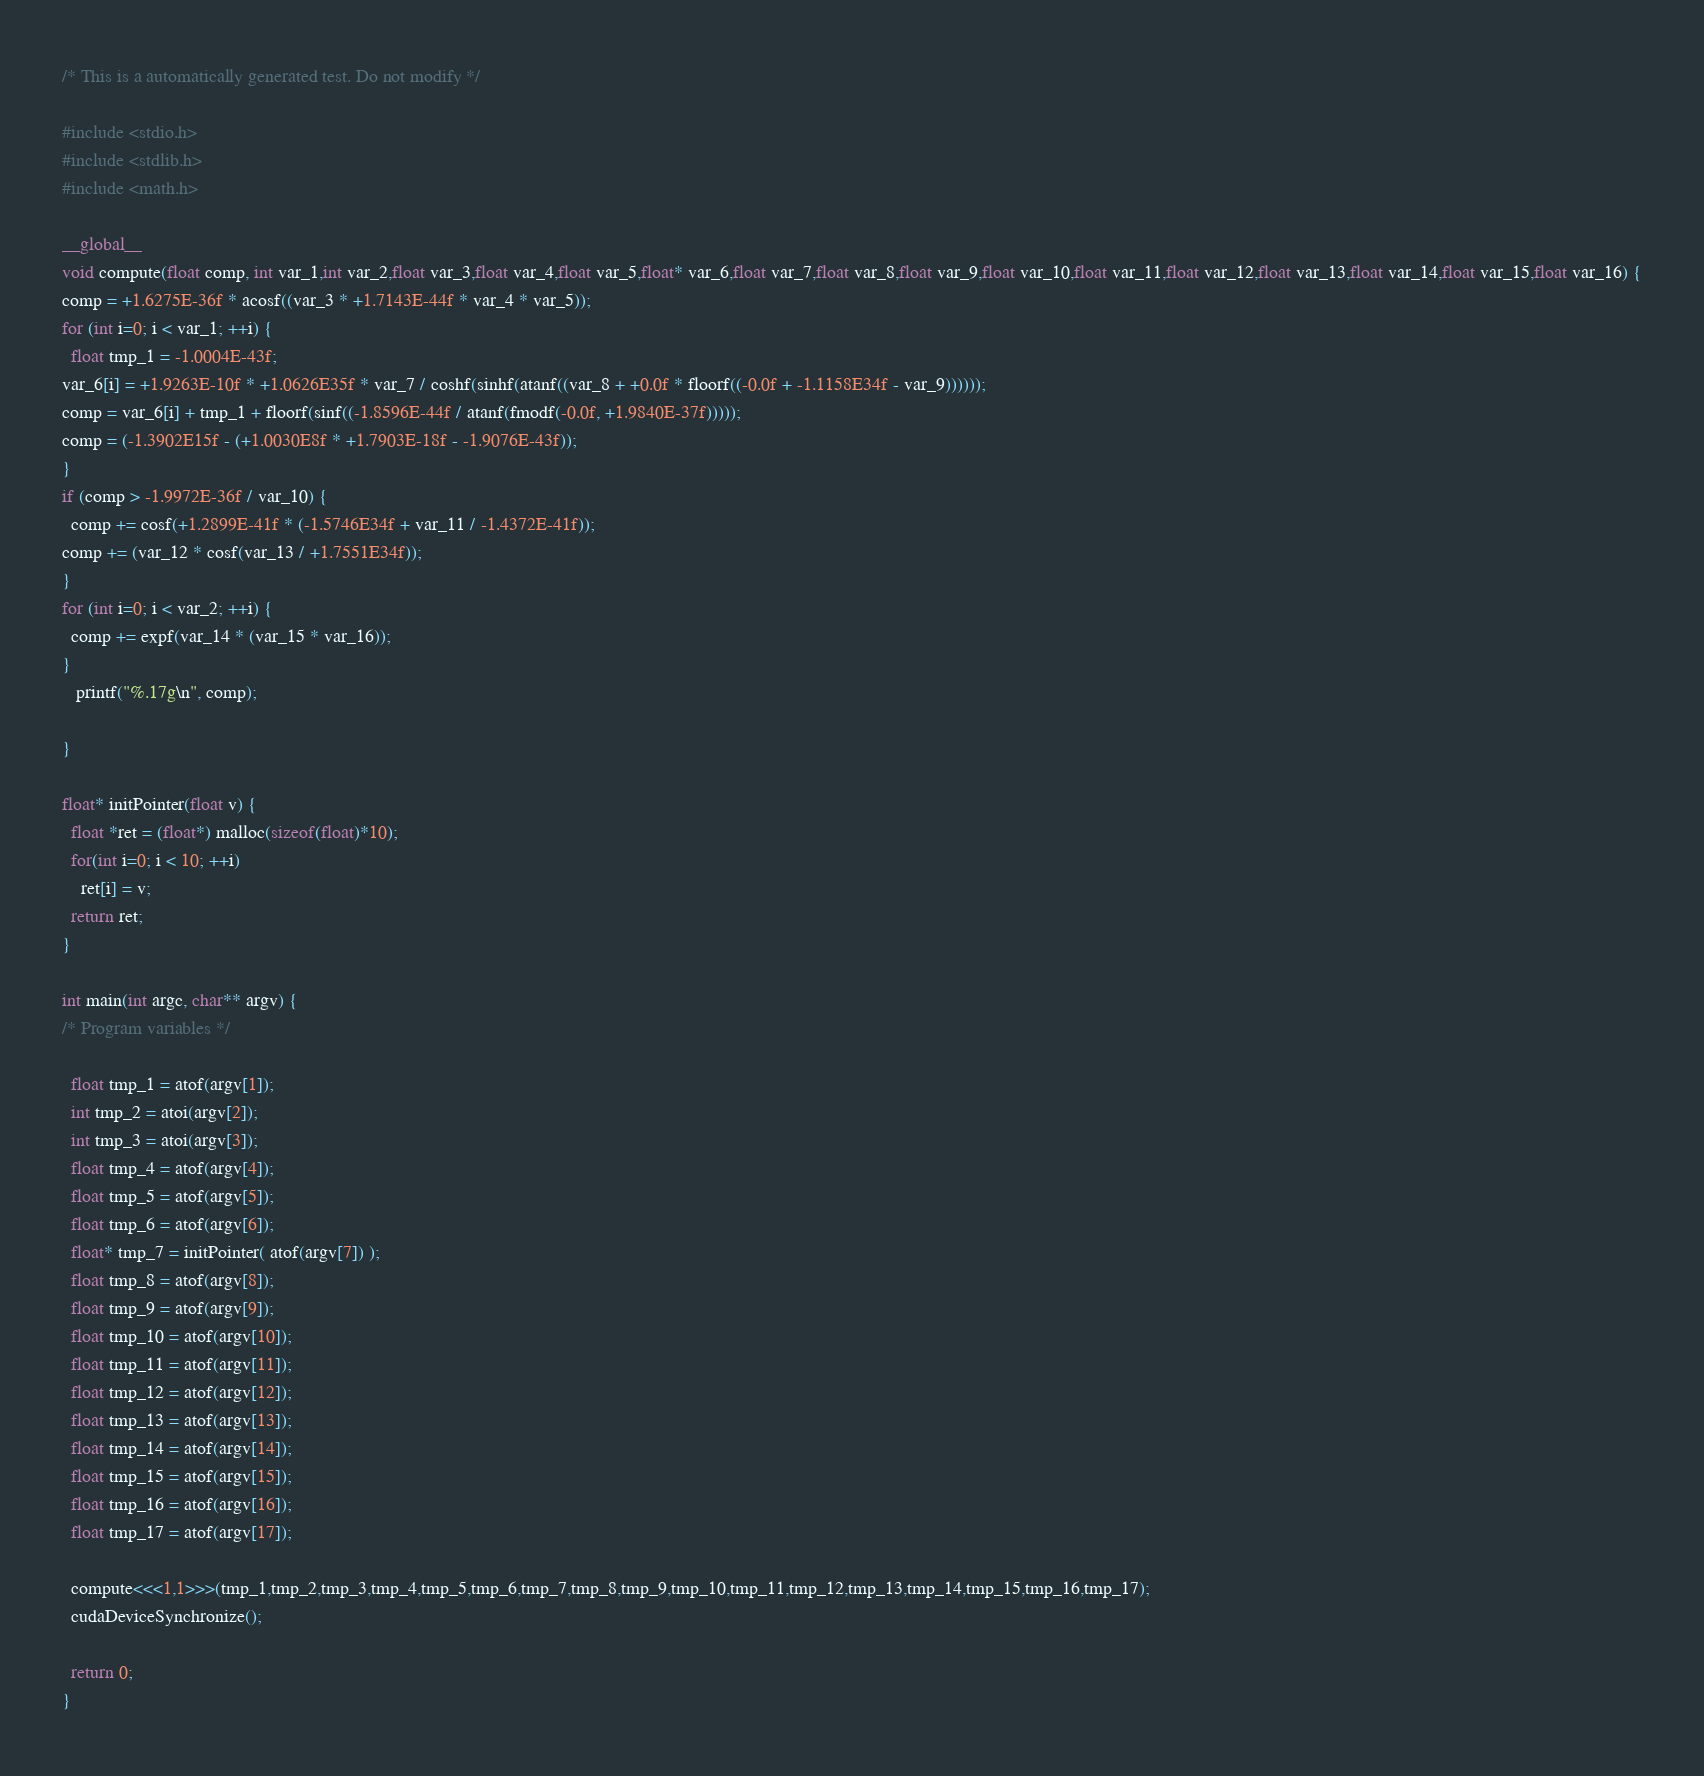<code> <loc_0><loc_0><loc_500><loc_500><_Cuda_>
/* This is a automatically generated test. Do not modify */

#include <stdio.h>
#include <stdlib.h>
#include <math.h>

__global__
void compute(float comp, int var_1,int var_2,float var_3,float var_4,float var_5,float* var_6,float var_7,float var_8,float var_9,float var_10,float var_11,float var_12,float var_13,float var_14,float var_15,float var_16) {
comp = +1.6275E-36f * acosf((var_3 * +1.7143E-44f * var_4 * var_5));
for (int i=0; i < var_1; ++i) {
  float tmp_1 = -1.0004E-43f;
var_6[i] = +1.9263E-10f * +1.0626E35f * var_7 / coshf(sinhf(atanf((var_8 + +0.0f * floorf((-0.0f + -1.1158E34f - var_9))))));
comp = var_6[i] + tmp_1 + floorf(sinf((-1.8596E-44f / atanf(fmodf(-0.0f, +1.9840E-37f)))));
comp = (-1.3902E15f - (+1.0030E8f * +1.7903E-18f - -1.9076E-43f));
}
if (comp > -1.9972E-36f / var_10) {
  comp += cosf(+1.2899E-41f * (-1.5746E34f + var_11 / -1.4372E-41f));
comp += (var_12 * cosf(var_13 / +1.7551E34f));
}
for (int i=0; i < var_2; ++i) {
  comp += expf(var_14 * (var_15 * var_16));
}
   printf("%.17g\n", comp);

}

float* initPointer(float v) {
  float *ret = (float*) malloc(sizeof(float)*10);
  for(int i=0; i < 10; ++i)
    ret[i] = v;
  return ret;
}

int main(int argc, char** argv) {
/* Program variables */

  float tmp_1 = atof(argv[1]);
  int tmp_2 = atoi(argv[2]);
  int tmp_3 = atoi(argv[3]);
  float tmp_4 = atof(argv[4]);
  float tmp_5 = atof(argv[5]);
  float tmp_6 = atof(argv[6]);
  float* tmp_7 = initPointer( atof(argv[7]) );
  float tmp_8 = atof(argv[8]);
  float tmp_9 = atof(argv[9]);
  float tmp_10 = atof(argv[10]);
  float tmp_11 = atof(argv[11]);
  float tmp_12 = atof(argv[12]);
  float tmp_13 = atof(argv[13]);
  float tmp_14 = atof(argv[14]);
  float tmp_15 = atof(argv[15]);
  float tmp_16 = atof(argv[16]);
  float tmp_17 = atof(argv[17]);

  compute<<<1,1>>>(tmp_1,tmp_2,tmp_3,tmp_4,tmp_5,tmp_6,tmp_7,tmp_8,tmp_9,tmp_10,tmp_11,tmp_12,tmp_13,tmp_14,tmp_15,tmp_16,tmp_17);
  cudaDeviceSynchronize();

  return 0;
}
</code> 